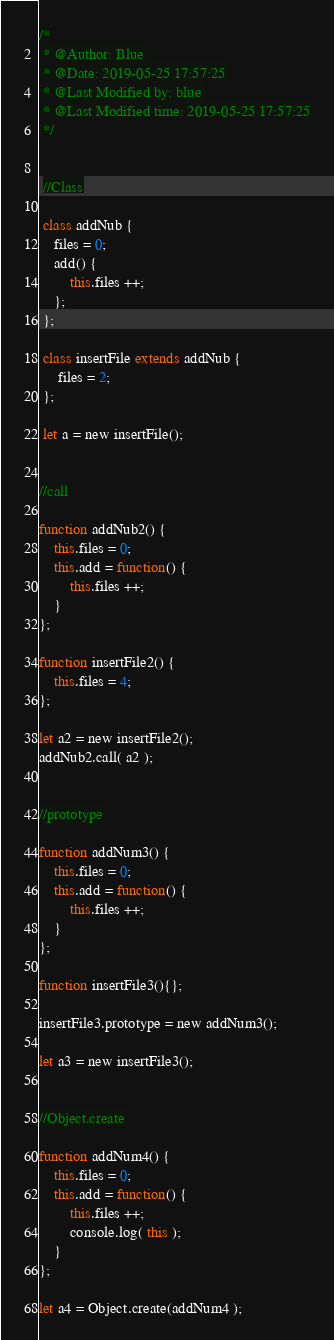Convert code to text. <code><loc_0><loc_0><loc_500><loc_500><_JavaScript_>/*
 * @Author: Blue
 * @Date: 2019-05-25 17:57:25
 * @Last Modified by: blue
 * @Last Modified time: 2019-05-25 17:57:25
 */


 //Class

 class addNub {
    files = 0;
    add() {
        this.files ++;
    };
 };

 class insertFile extends addNub {
     files = 2;
 };
 
 let a = new insertFile();


//call

function addNub2() {
    this.files = 0;
    this.add = function() {
        this.files ++;
    }
};

function insertFile2() {
    this.files = 4;
};

let a2 = new insertFile2();
addNub2.call( a2 );


//prototype

function addNum3() {
    this.files = 0;
    this.add = function() {
        this.files ++;
    }
};

function insertFile3(){};

insertFile3.prototype = new addNum3();

let a3 = new insertFile3();


//Object.create

function addNum4() {
    this.files = 0;
    this.add = function() {
        this.files ++;
        console.log( this );
    }
};

let a4 = Object.create(addNum4 );

</code> 